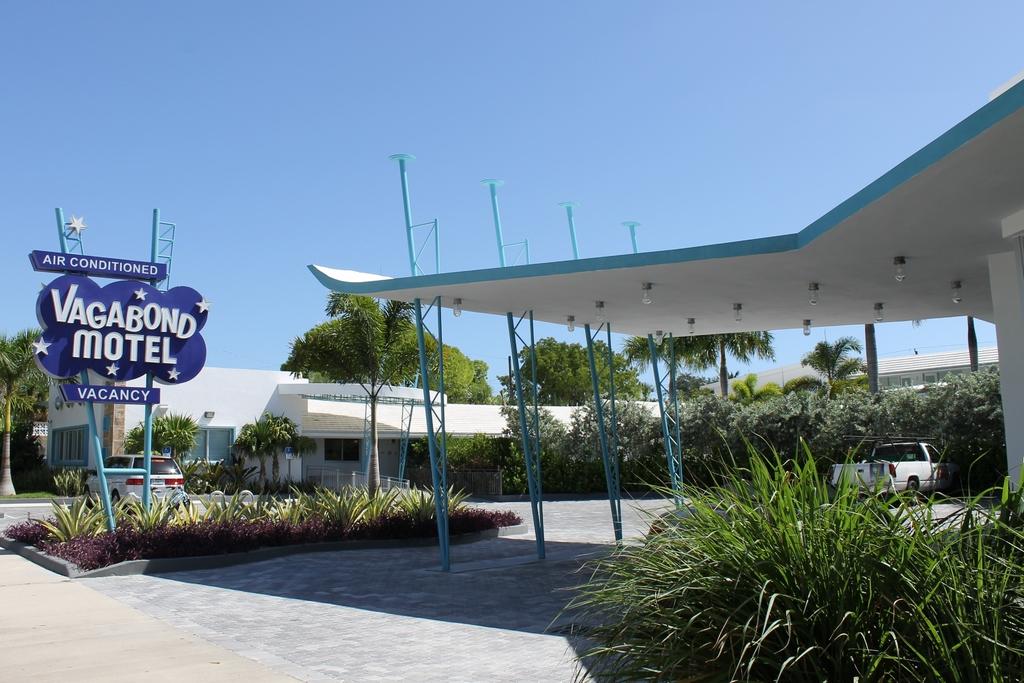What is the name of this place?
Offer a very short reply. Vagabond motel. What kind of air?
Your answer should be very brief. Conditioned. 